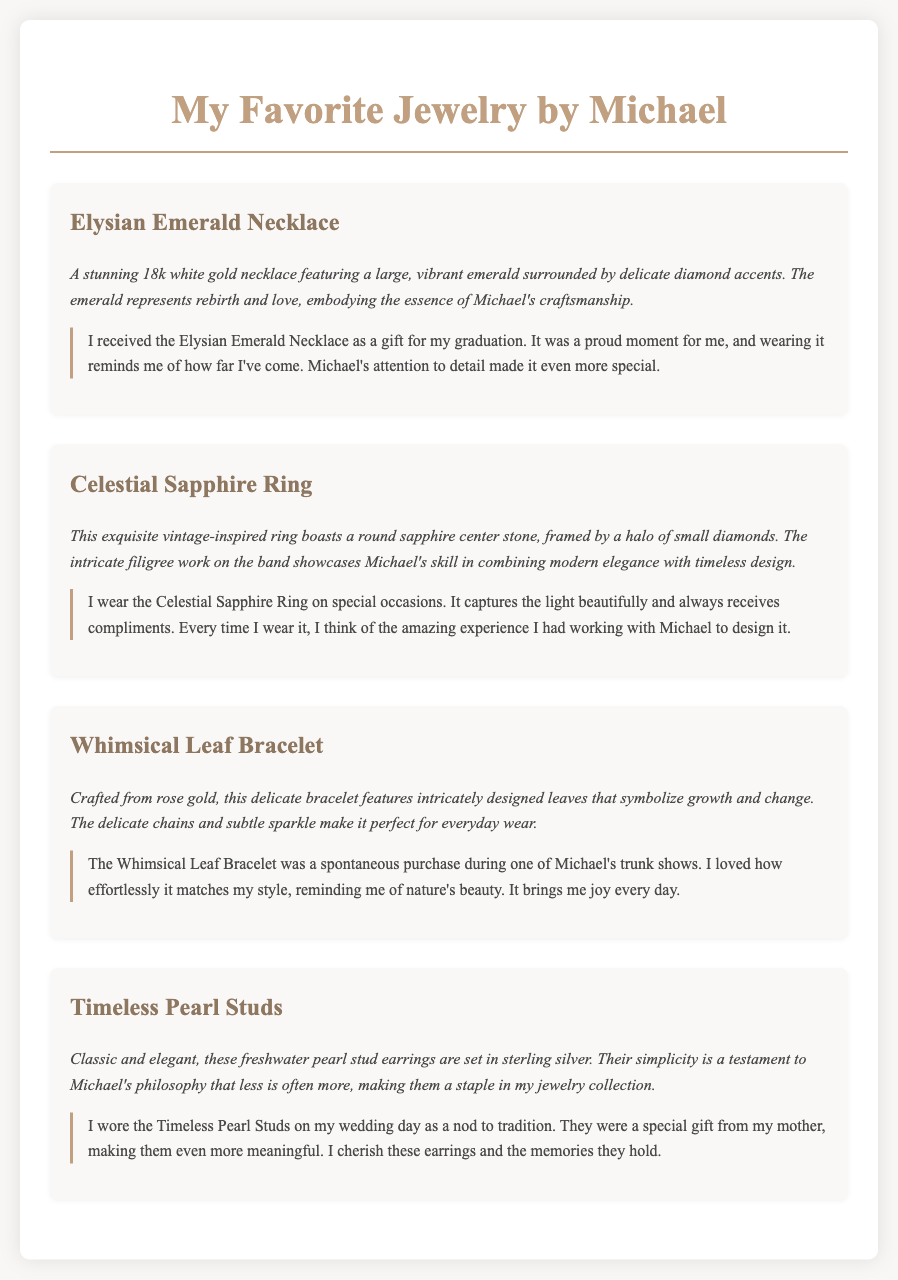What is the title of the document? The title of the document is found in the header and summarizes the content about favorite jewelry.
Answer: My Favorite Jewelry by Michael What kind of metal is used in the Elysian Emerald Necklace? The Elysian Emerald Necklace description specifies the metal used in its construction.
Answer: 18k white gold Which piece showcases a vintage-inspired design? The Celestial Sapphire Ring is described as vintage-inspired, highlighting its unique style.
Answer: Celestial Sapphire Ring What gemstones are used in the Timeless Pearl Studs? The description specifies the type of pearls used in the Timeless Pearl Studs.
Answer: freshwater pearls What personal significance does the Elysian Emerald Necklace hold for the owner? The personal story shared indicates a special occasion related to the owner’s achievement.
Answer: graduation How does the Whimsical Leaf Bracelet contribute to the owner's style? The owner mentions its effortless matching with their style, reflecting a personal connection.
Answer: matches my style What does the Celestial Sapphire Ring symbolize for the owner? The owner connects the ring to special occasions and compliments received, indicating its importance.
Answer: special occasions Which item was purchased at a trunk show? The specific item mentioned in the story about a spontaneous purchase emphasizes a memorable experience.
Answer: Whimsical Leaf Bracelet 